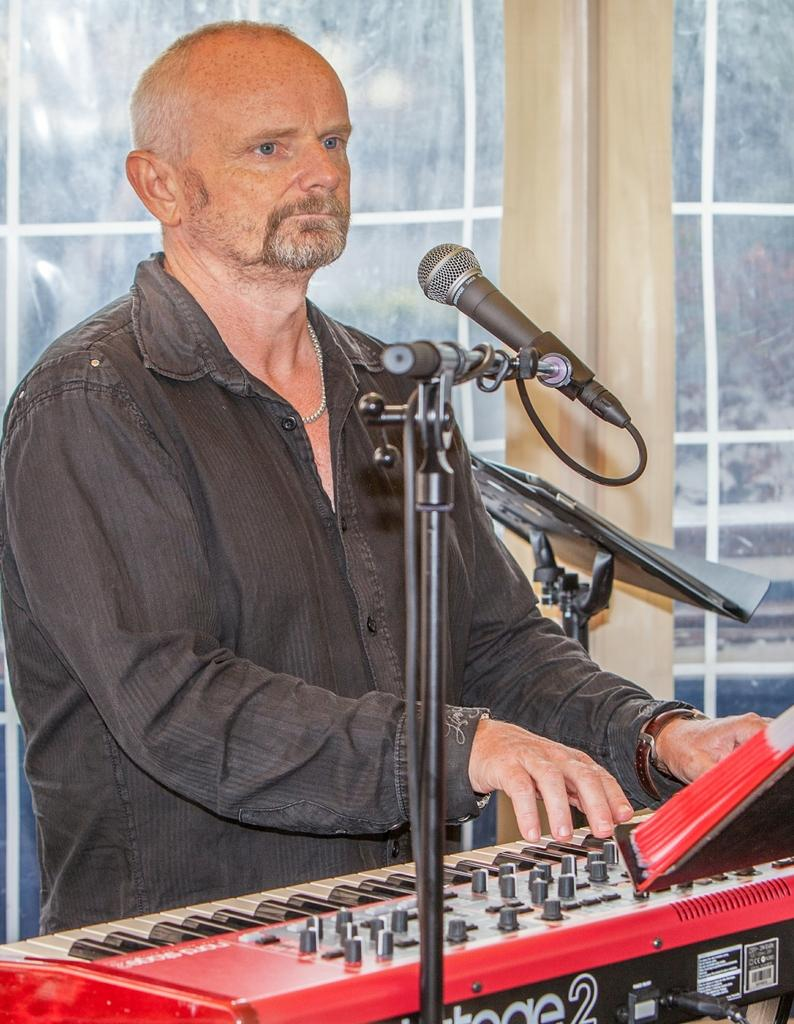What is the man in the image doing? A: The man is playing a piano. What object is in front of the man? There is a microphone in front of the man. What can be seen on the right side of the image? There is a music stand on the right side of the image. What is visible in the background of the image? There is glass visible in the background of the image. How does the sun affect the man's performance in the image? The image does not show the sun or any outdoor setting, so it cannot be determined how the sun might affect the man's performance. 